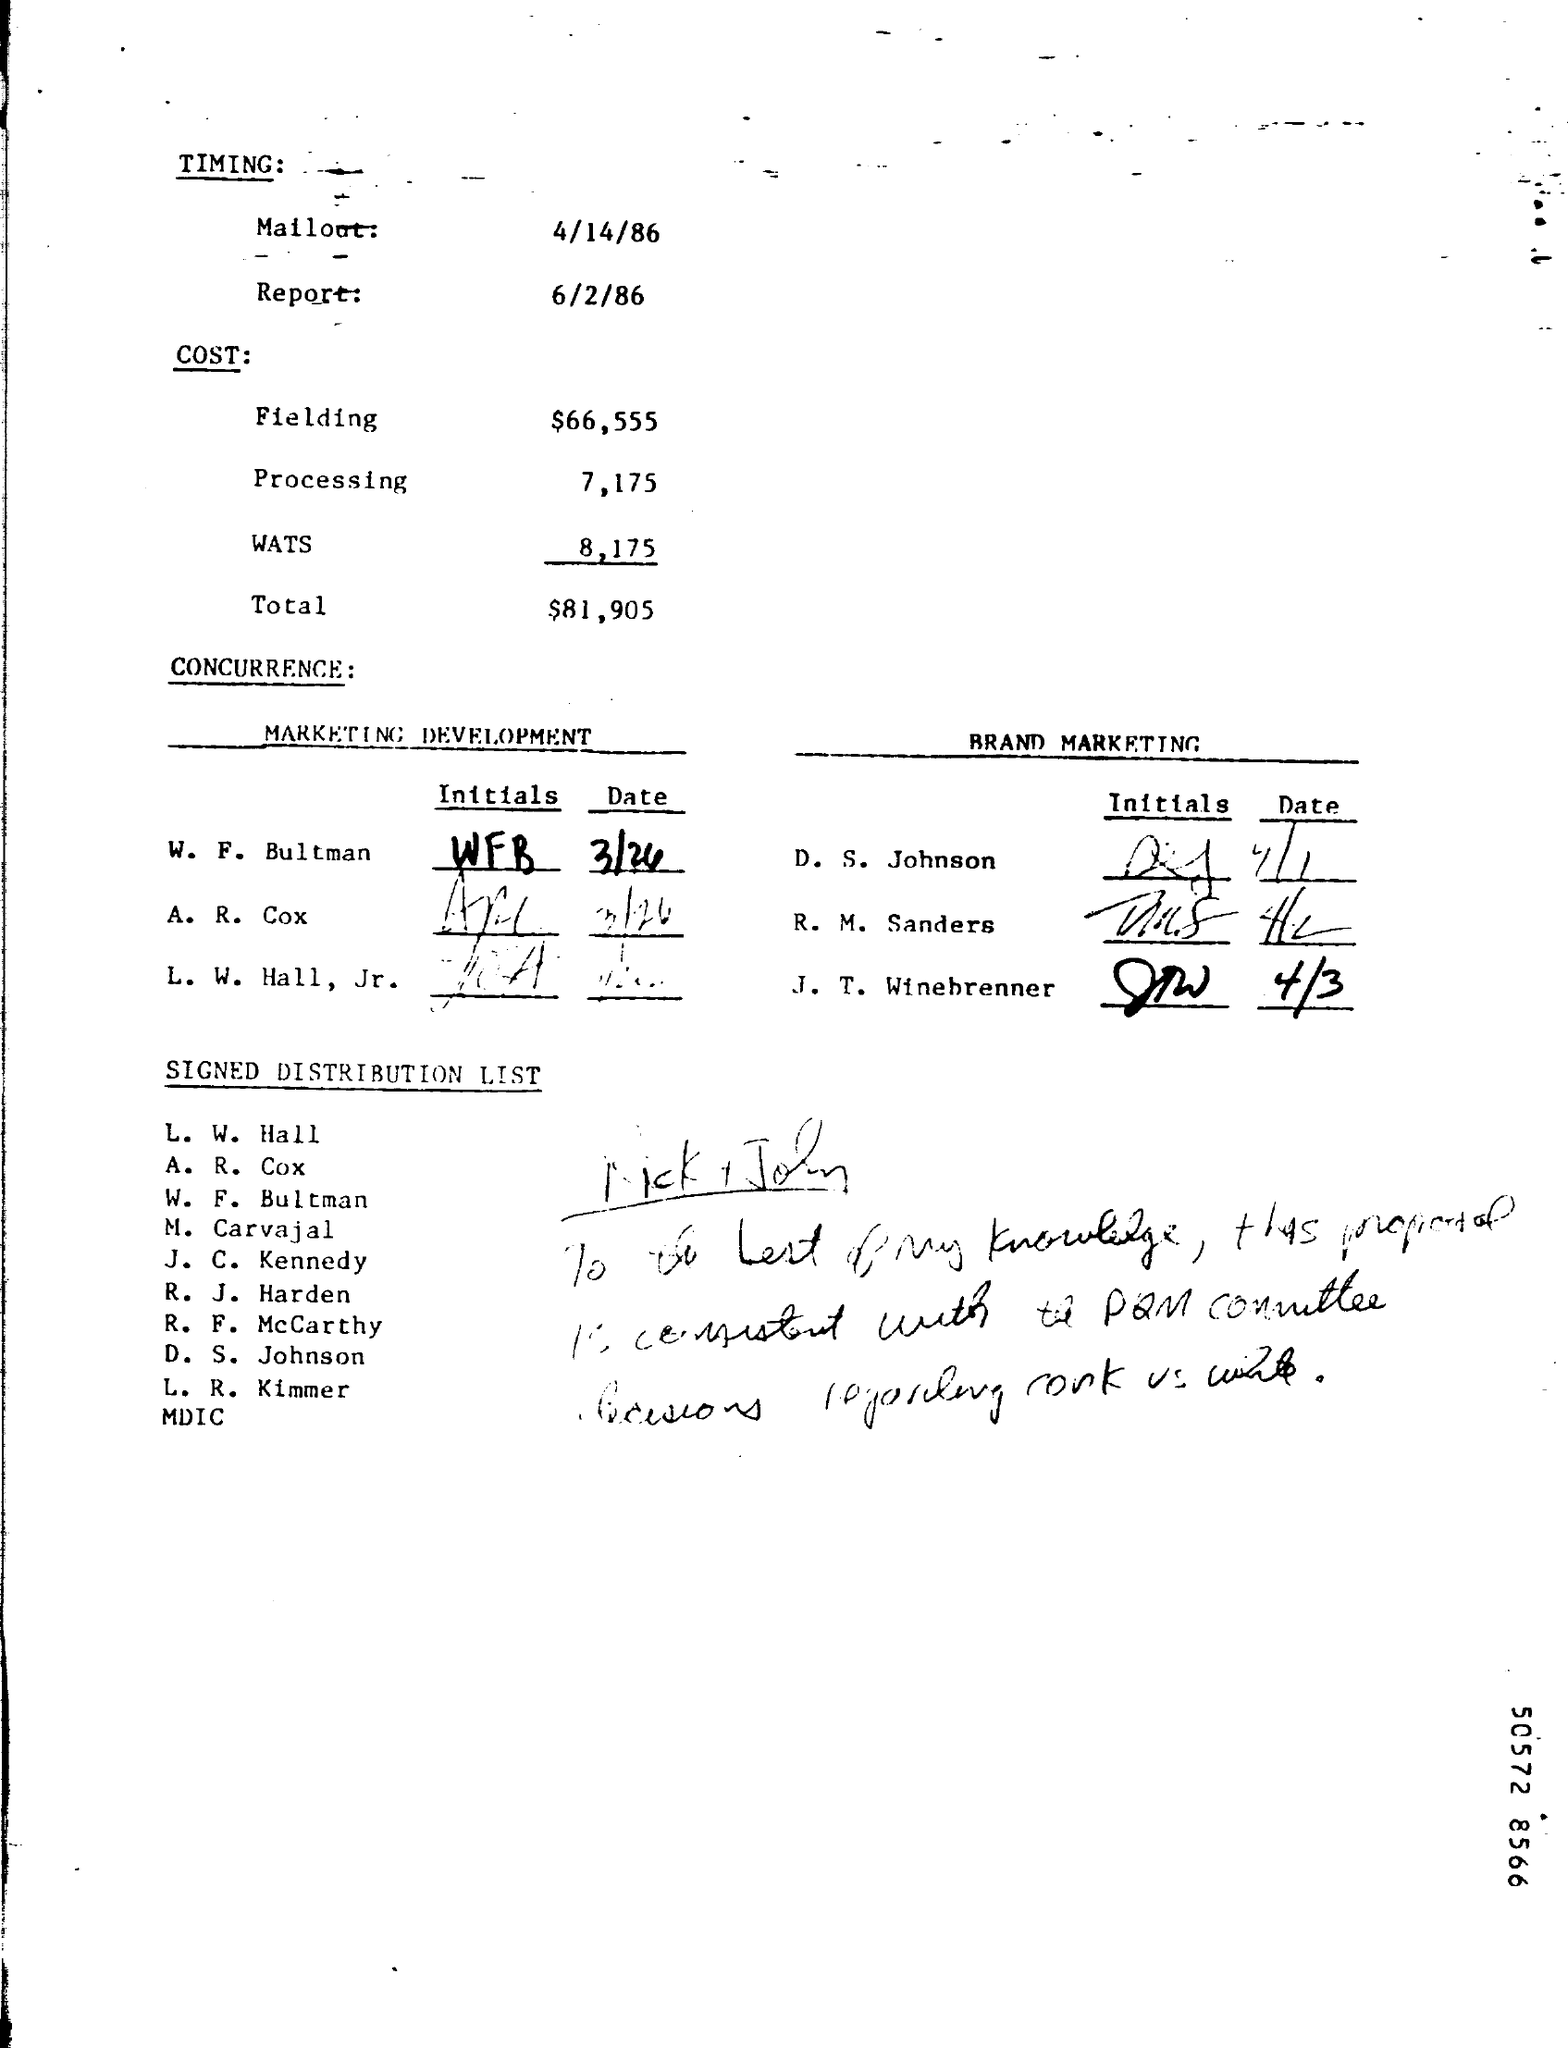What is the Timing for Mailout?
Your response must be concise. 4/14/86. What is the Timing for Report?
Provide a succinct answer. 6/2/86. What is the Fielding Cost?
Provide a short and direct response. $66,555. What is the Processing Cost?
Offer a terse response. 7,175. What is the WATS Cost?
Provide a short and direct response. 8,175. What is the Total Cost?
Ensure brevity in your answer.  $81,905. 